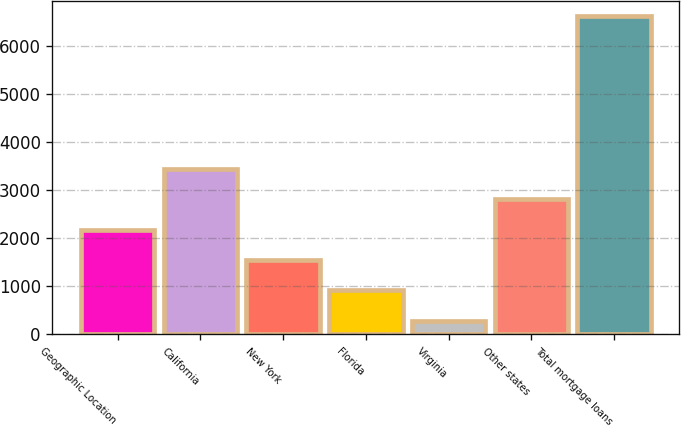Convert chart. <chart><loc_0><loc_0><loc_500><loc_500><bar_chart><fcel>Geographic Location<fcel>California<fcel>New York<fcel>Florida<fcel>Virginia<fcel>Other states<fcel>Total mortgage loans<nl><fcel>2181.3<fcel>3448.3<fcel>1547.8<fcel>914.3<fcel>280.8<fcel>2814.8<fcel>6615.8<nl></chart> 